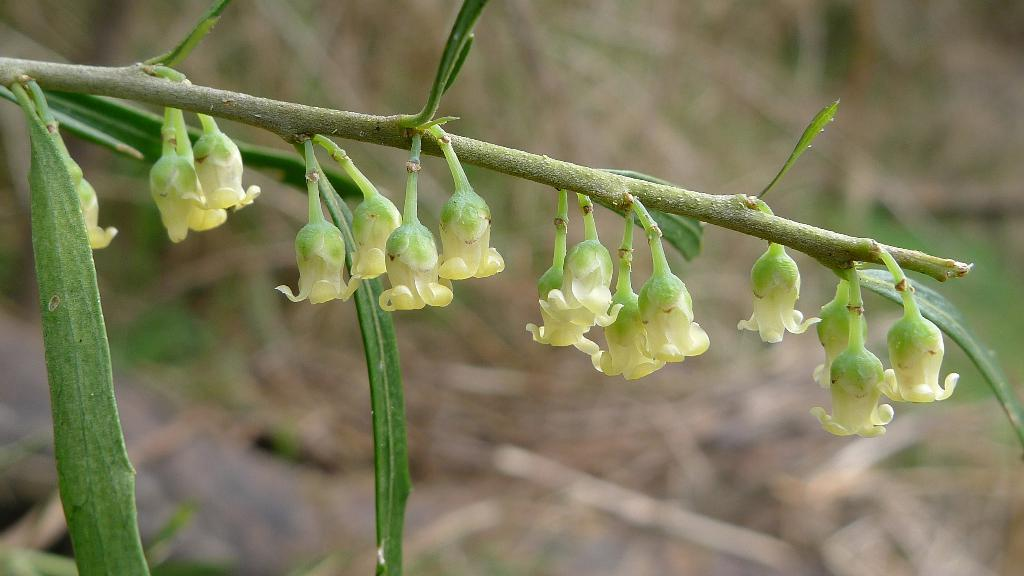What is the main subject of the image? The main subject of the image is a branch of a plant. What can be observed on the branch? There are flower buds on the branch. How does the plant express its emotions by crying in the image? Plants do not have the ability to express emotions or cry, so this is not present in the image. 